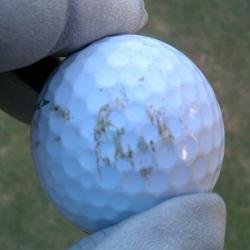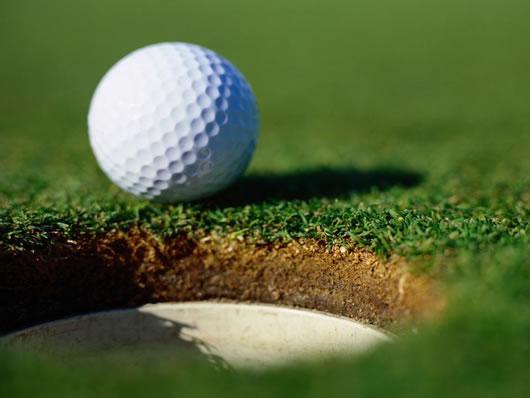The first image is the image on the left, the second image is the image on the right. Given the left and right images, does the statement "Part of a hand is touching one real golf ball in the lefthand image." hold true? Answer yes or no. Yes. The first image is the image on the left, the second image is the image on the right. Assess this claim about the two images: "The left and right image contains the same number of golf balls with at least one in a person's hand.". Correct or not? Answer yes or no. Yes. 